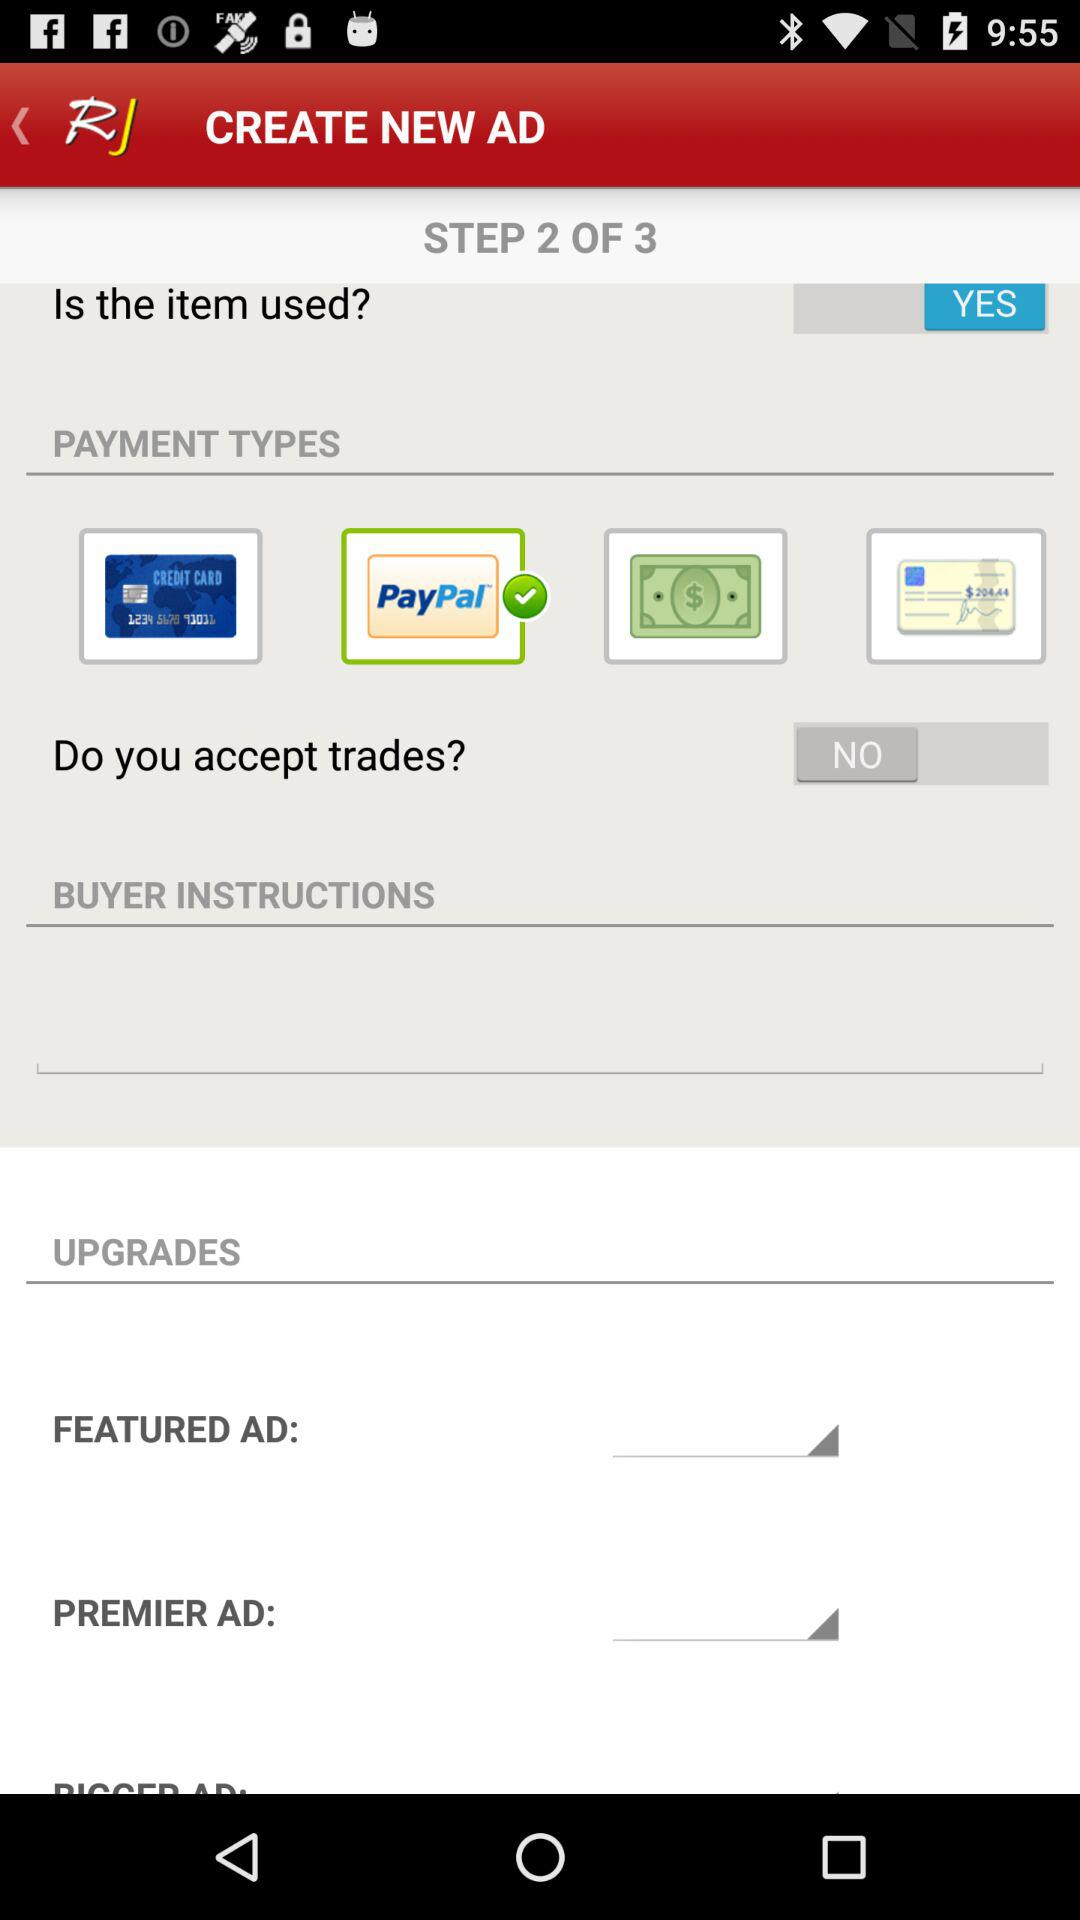What is the current status of "Do you accept trades?"? The current status of "Do you accept trades?" is "NO". 